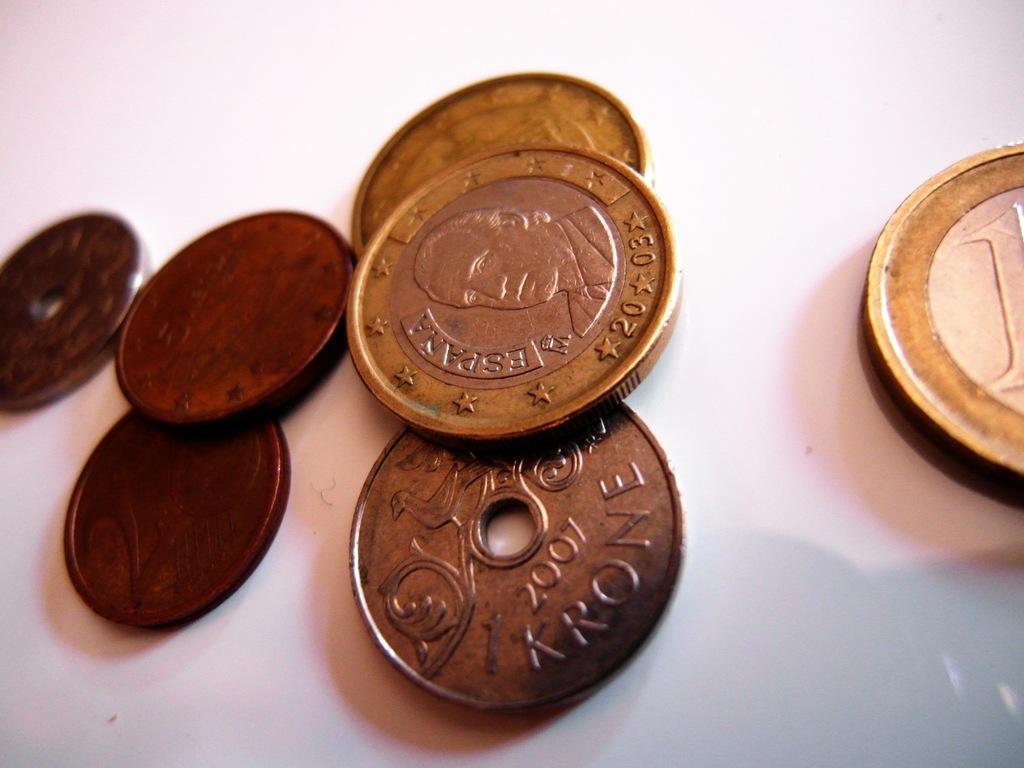What year is printed on the krone coin?
Your answer should be very brief. 2007. What numbers are on the coin on top?
Your answer should be compact. 2003. 